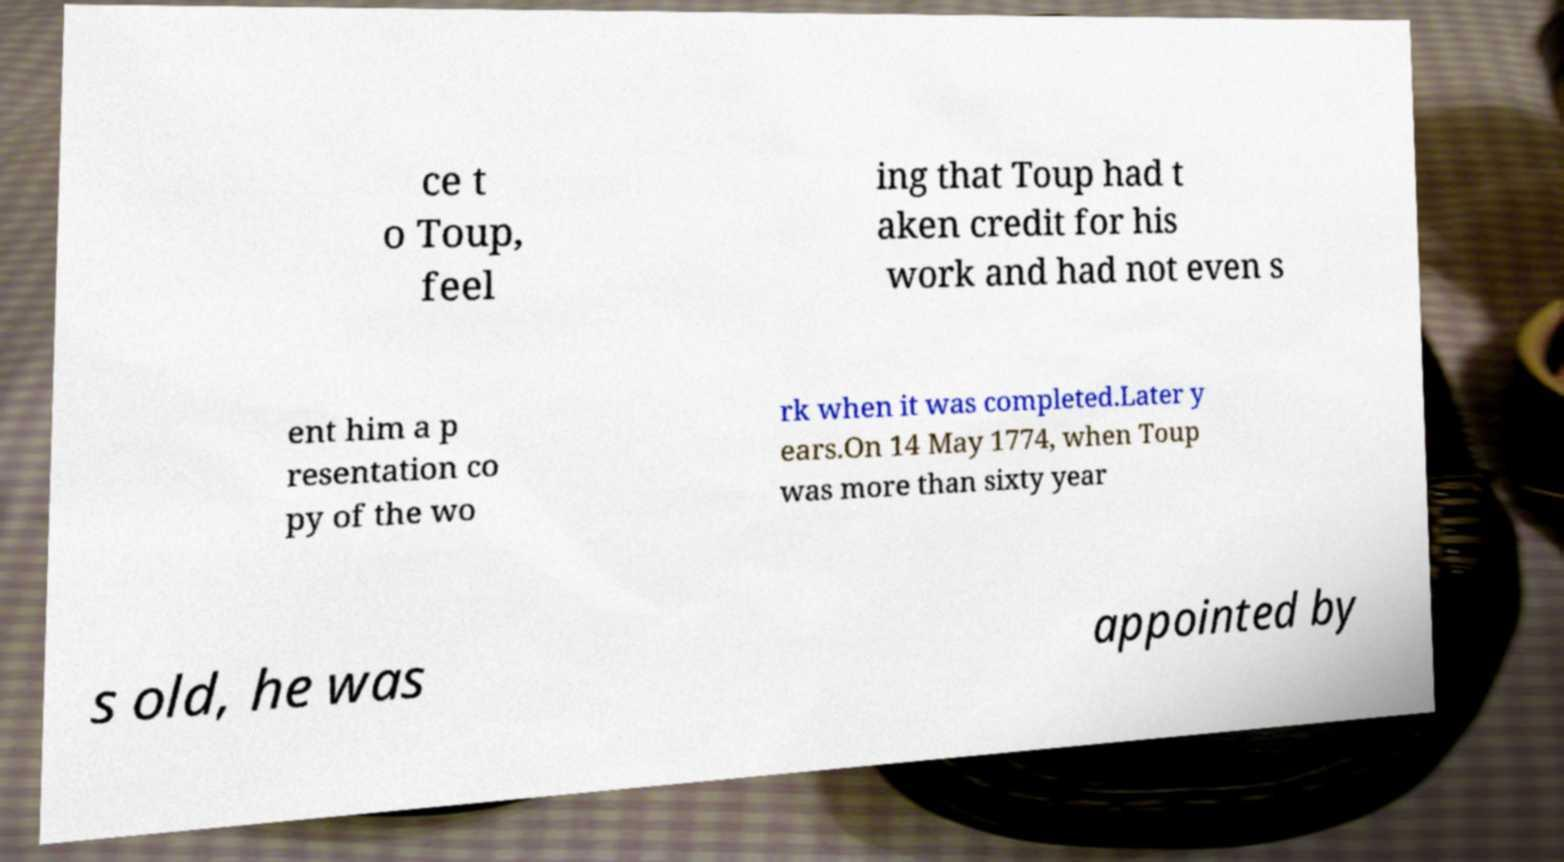Can you accurately transcribe the text from the provided image for me? ce t o Toup, feel ing that Toup had t aken credit for his work and had not even s ent him a p resentation co py of the wo rk when it was completed.Later y ears.On 14 May 1774, when Toup was more than sixty year s old, he was appointed by 